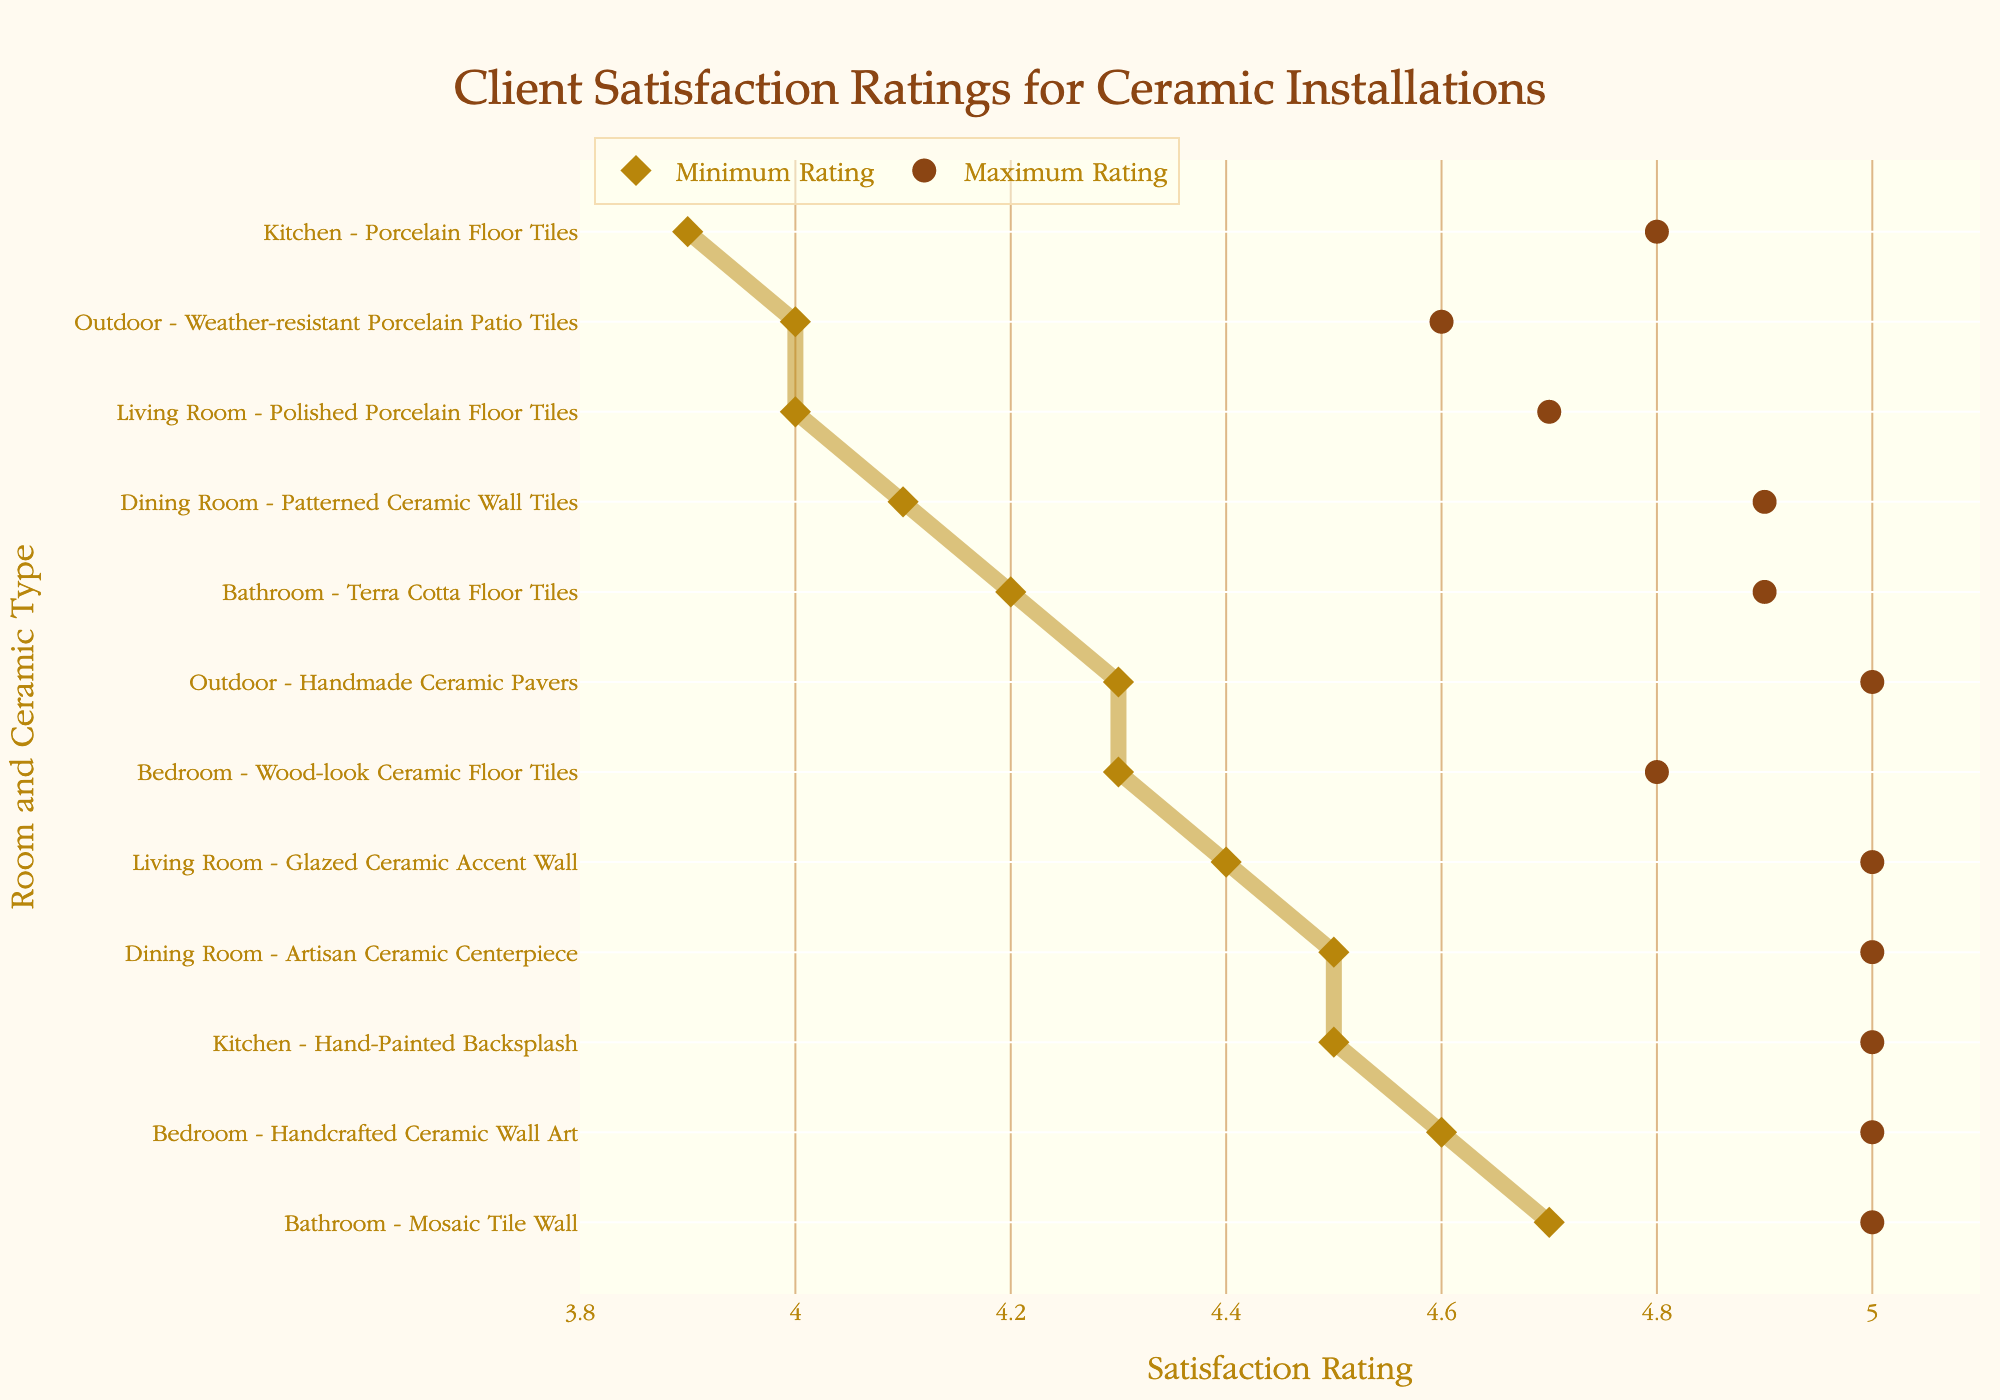What is the title of the plot? The title is usually displayed prominently at the top center of the plot. Here, it states "Client Satisfaction Ratings for Ceramic Installations".
Answer: Client Satisfaction Ratings for Ceramic Installations What are the minimum and maximum ratings for Hand-Painted Backsplash in the Kitchen? This information is visible by locating the range for "Kitchen - Hand-Painted Backsplash" on the y-axis. The dots indicate the minimum and maximum ratings.
Answer: 4.5, 5.0 Which room and ceramic type combination has the highest minimum satisfaction rating? By looking at all the minimum rating points, the highest one among them corresponds to the "Bathroom - Mosaic Tile Wall" combination. The minimum rating for it is 4.7.
Answer: Bathroom - Mosaic Tile Wall How many different room and ceramic type combinations have a maximum rating of 5.0? By counting the number of points that reach the maximum rating of 5.0, we find the following combinations: "Kitchen - Hand-Painted Backsplash", "Bathroom - Mosaic Tile Wall", "Living Room - Glazed Ceramic Accent Wall", "Bedroom - Handcrafted Ceramic Wall Art", "Dining Room - Artisan Ceramic Centerpiece".
Answer: 5 Which room and ceramic type combination has the largest range between minimum and maximum satisfaction ratings? To find this, we calculate the differences between max and min ratings for all combinations and compare them. "Outdoor - Weather-resistant Porcelain Patio Tiles" has the largest range: 4.6 - 4.0 = 0.6.
Answer: Outdoor - Weather-resistant Porcelain Patio Tiles Is there any room where all listed ceramic types have a minimum rating above 4.0? By checking each room's listed ceramic types, we observe that all entries for each room have minimum ratings above 4.0. All rooms satisfy this condition.
Answer: All rooms Which room and ceramic type combination has the highest overall client satisfaction? The combination with the highest overall client satisfaction can be determined by finding the highest maximum rating. Multiple combinations have a maximum rating of 5.0, such as "Bathroom - Mosaic Tile Wall".
Answer: Bathroom - Mosaic Tile Wall What is the average minimum rating for the ceramic installations in the Kitchen? To find this, we add the minimum ratings for ceramic installations in the Kitchen and divide by the number of installations. (4.5 + 3.9) / 2 = 4.2.
Answer: 4.2 